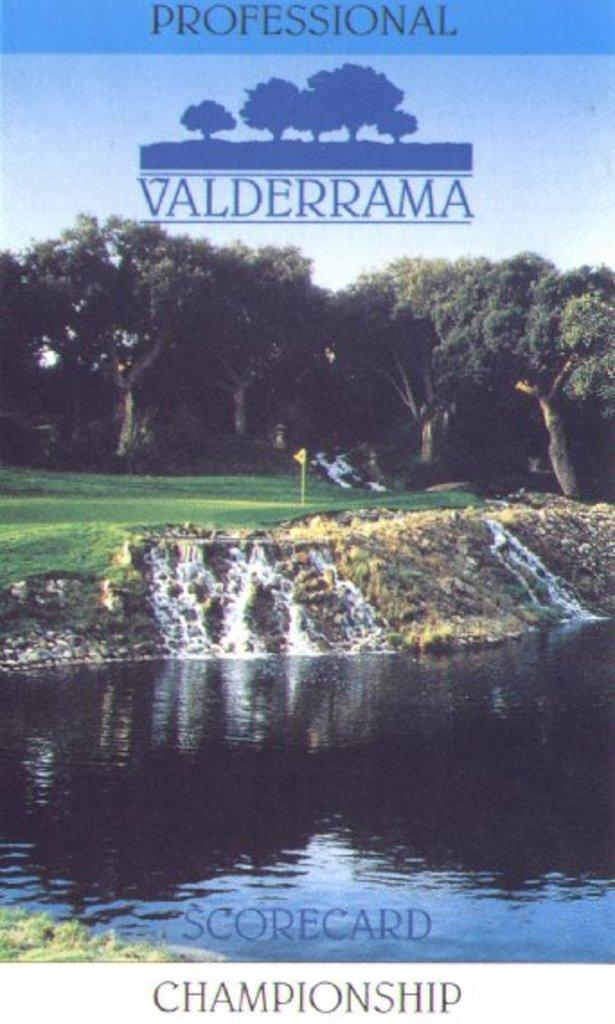What event is this scorecard for?
Make the answer very short. Championship. What level of competition is this?
Your answer should be compact. Professional. 